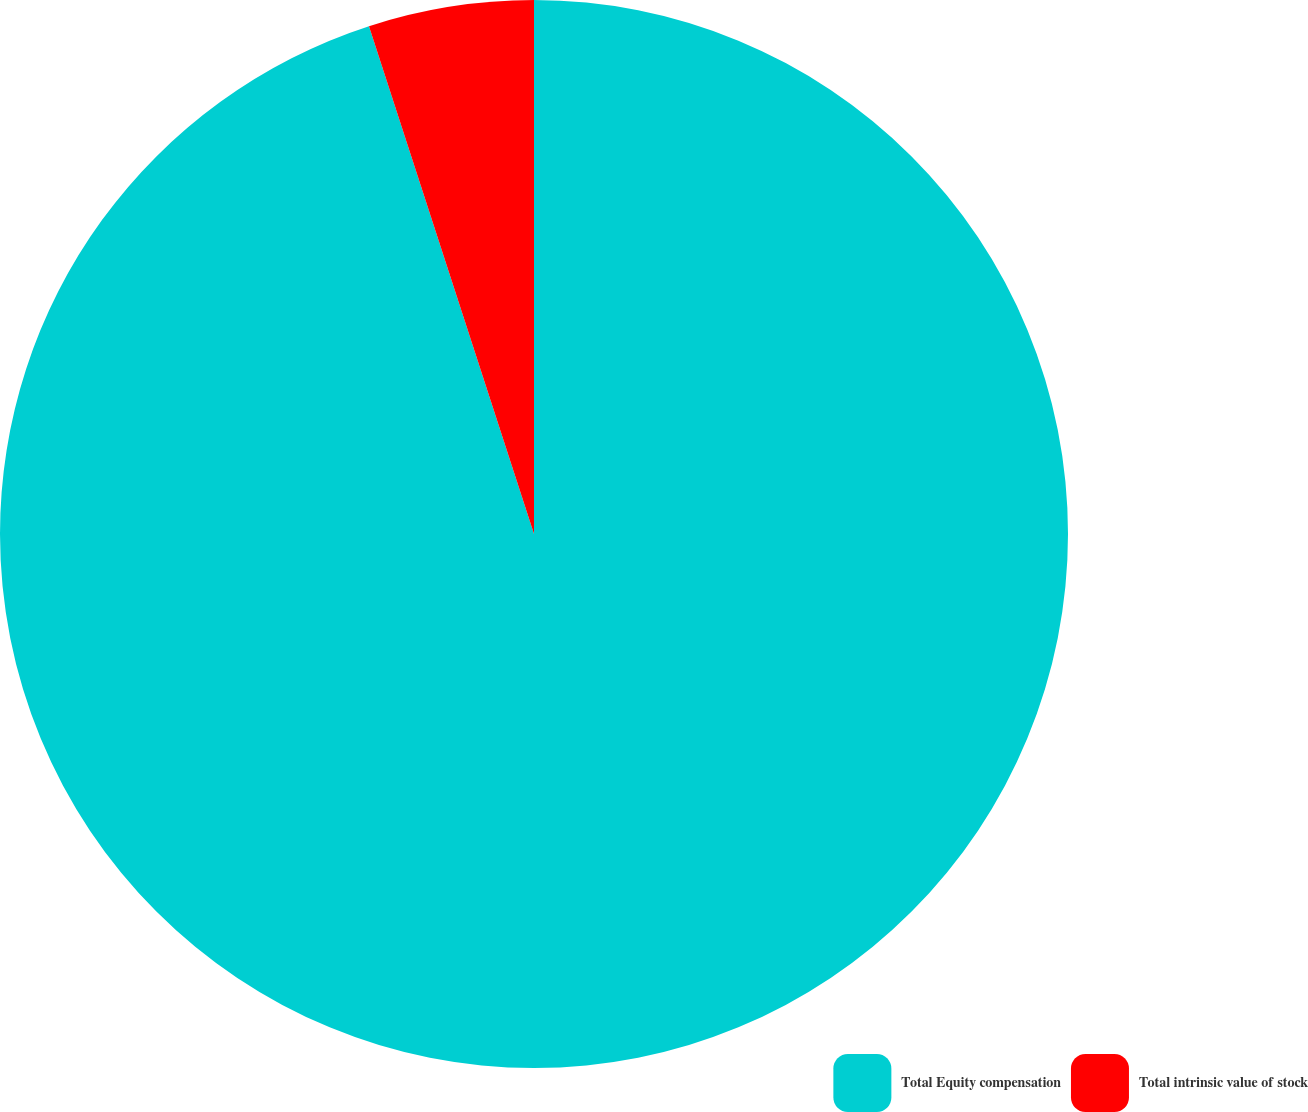<chart> <loc_0><loc_0><loc_500><loc_500><pie_chart><fcel>Total Equity compensation<fcel>Total intrinsic value of stock<nl><fcel>95.0%<fcel>5.0%<nl></chart> 